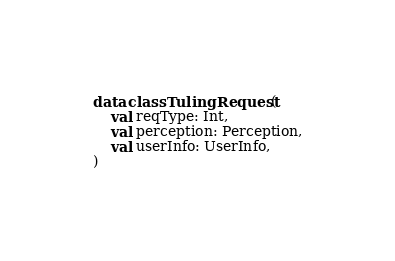<code> <loc_0><loc_0><loc_500><loc_500><_Kotlin_>

data class TulingRequest(
    val reqType: Int,
    val perception: Perception,
    val userInfo: UserInfo,
)
</code> 